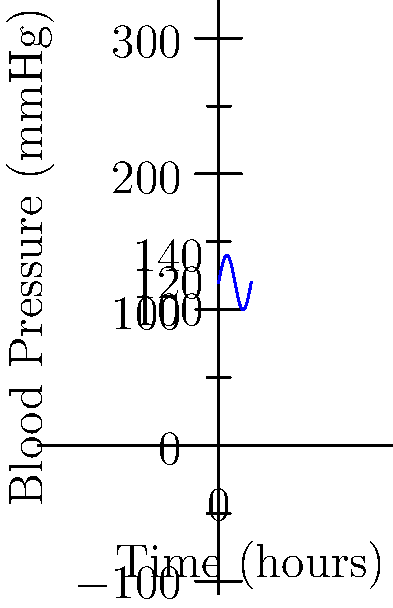As a primary care physician providing free medical services, you're monitoring a patient's blood pressure throughout the day. The graph shows the patient's blood pressure (in mmHg) as a function of time (in hours). If the function representing the blood pressure is given by $f(t) = 120 + 20\sin(\frac{\pi t}{12})$, where $t$ is time in hours, calculate the average blood pressure over a 24-hour period. To find the average blood pressure over a 24-hour period, we need to calculate the area under the curve and divide it by the total time period.

1) The average value of a function $f(t)$ over an interval $[a,b]$ is given by:

   $\text{Average} = \frac{1}{b-a} \int_{a}^{b} f(t) dt$

2) In this case, $a=0$, $b=24$, and $f(t) = 120 + 20\sin(\frac{\pi t}{12})$

3) Let's calculate the integral:

   $\int_{0}^{24} (120 + 20\sin(\frac{\pi t}{12})) dt$

4) Integrate the constant term:
   $120t |_{0}^{24} = 120 \cdot 24 = 2880$

5) For the sine term:
   $20 \int_{0}^{24} \sin(\frac{\pi t}{12}) dt$
   
   $= 20 \cdot (-\frac{12}{\pi}) \cos(\frac{\pi t}{12}) |_{0}^{24}$
   
   $= -\frac{240}{\pi} [\cos(2\pi) - \cos(0)] = 0$

6) The total integral is therefore 2880.

7) Divide by the time period:
   $\frac{2880}{24} = 120$

Therefore, the average blood pressure over the 24-hour period is 120 mmHg.
Answer: 120 mmHg 